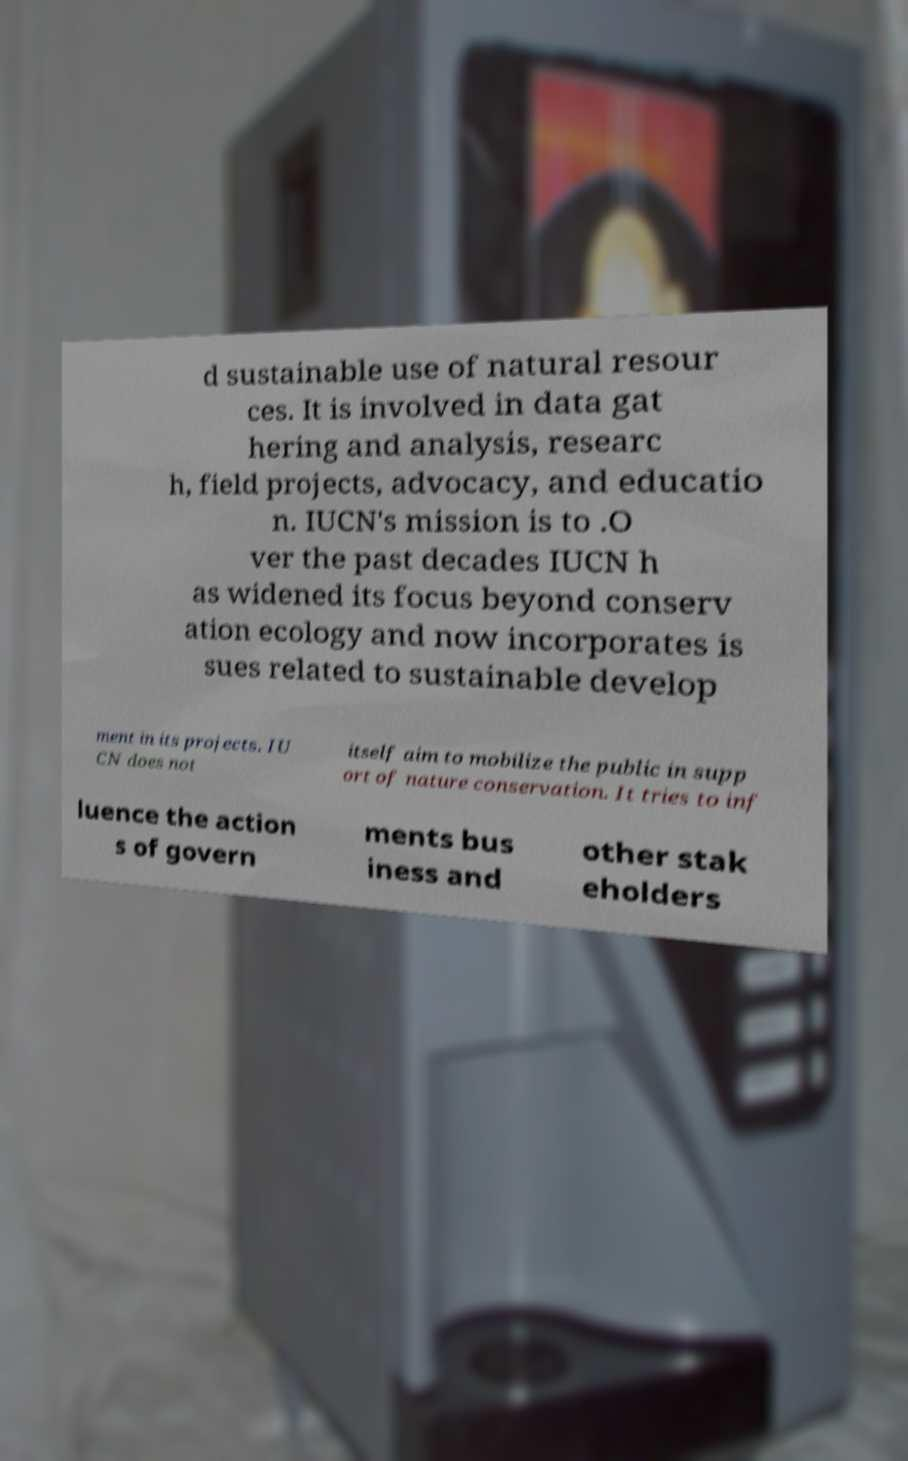Could you assist in decoding the text presented in this image and type it out clearly? d sustainable use of natural resour ces. It is involved in data gat hering and analysis, researc h, field projects, advocacy, and educatio n. IUCN's mission is to .O ver the past decades IUCN h as widened its focus beyond conserv ation ecology and now incorporates is sues related to sustainable develop ment in its projects. IU CN does not itself aim to mobilize the public in supp ort of nature conservation. It tries to inf luence the action s of govern ments bus iness and other stak eholders 